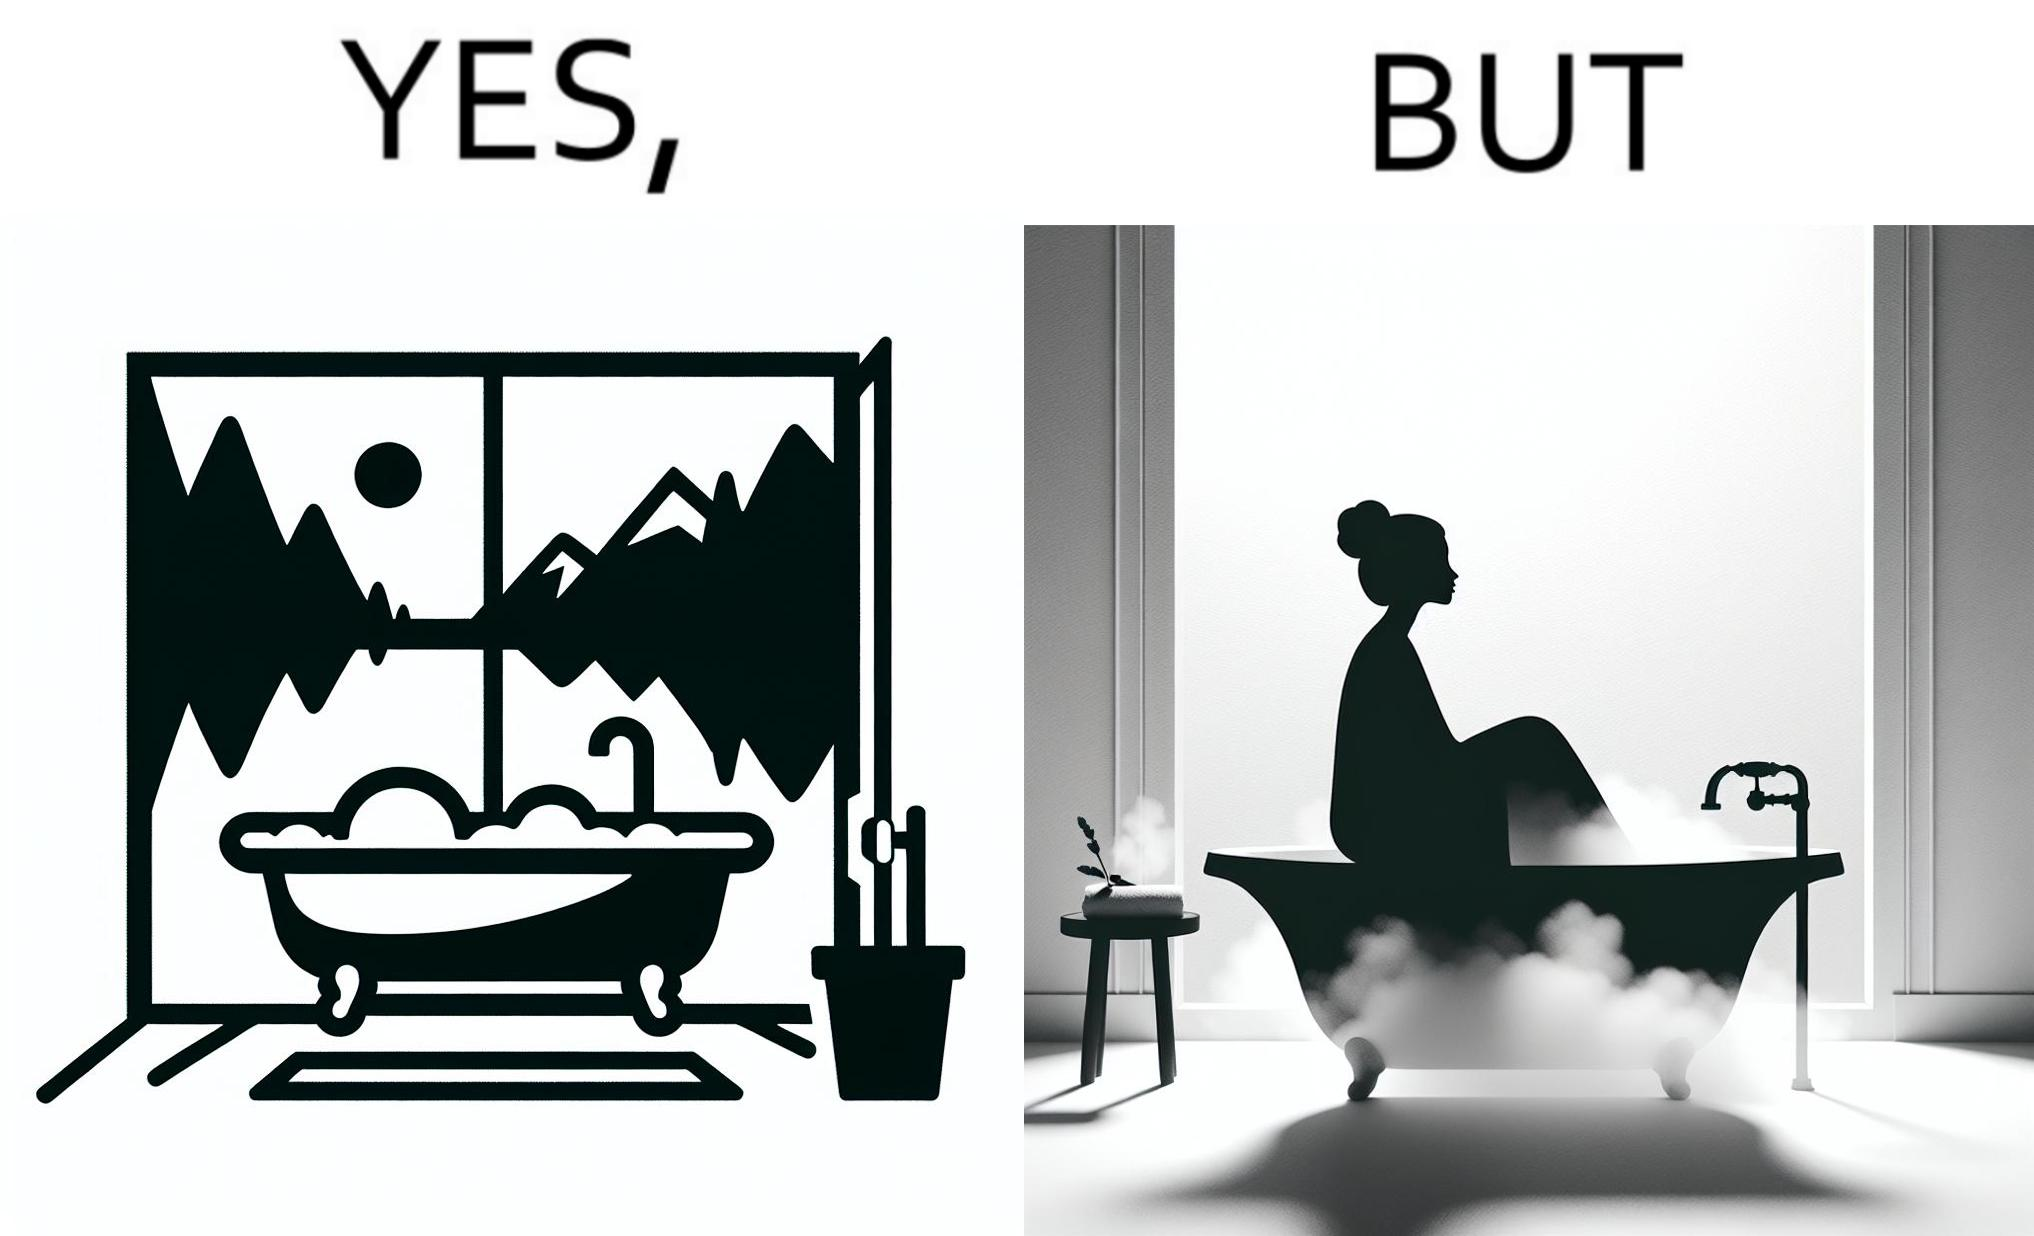Is this a satirical image? Yes, this image is satirical. 